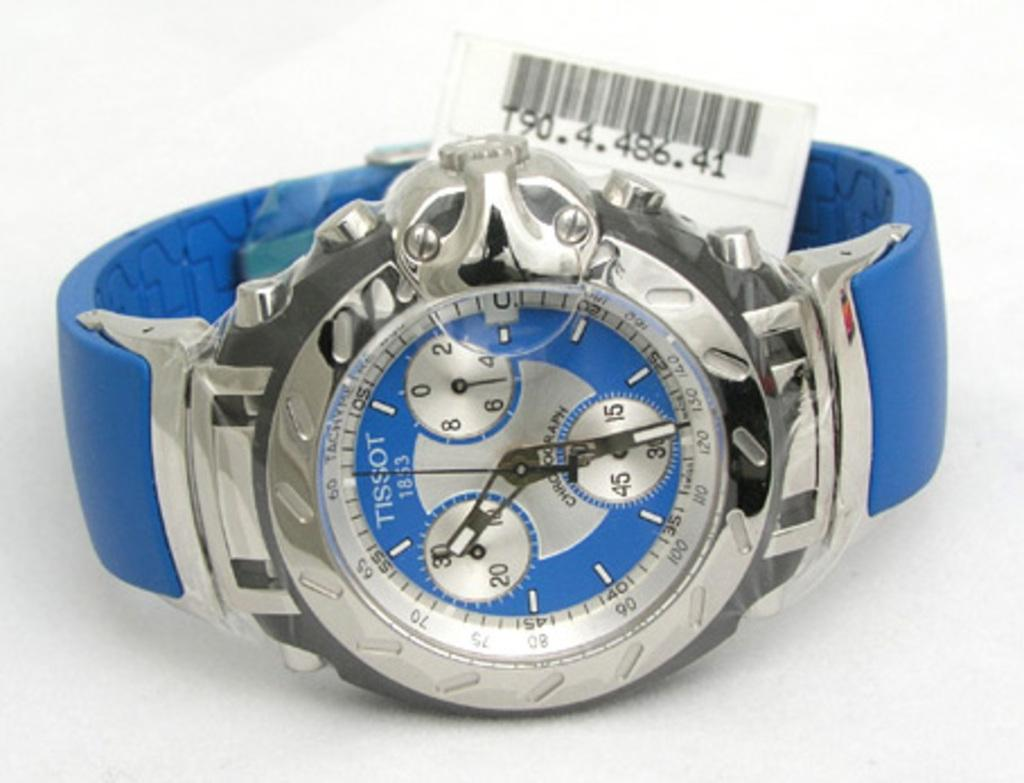<image>
Describe the image concisely. White and blue watch which says TISSOT on the front. 